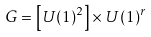<formula> <loc_0><loc_0><loc_500><loc_500>G = \left [ U ( 1 ) ^ { 2 } \right ] \times U ( 1 ) ^ { r }</formula> 